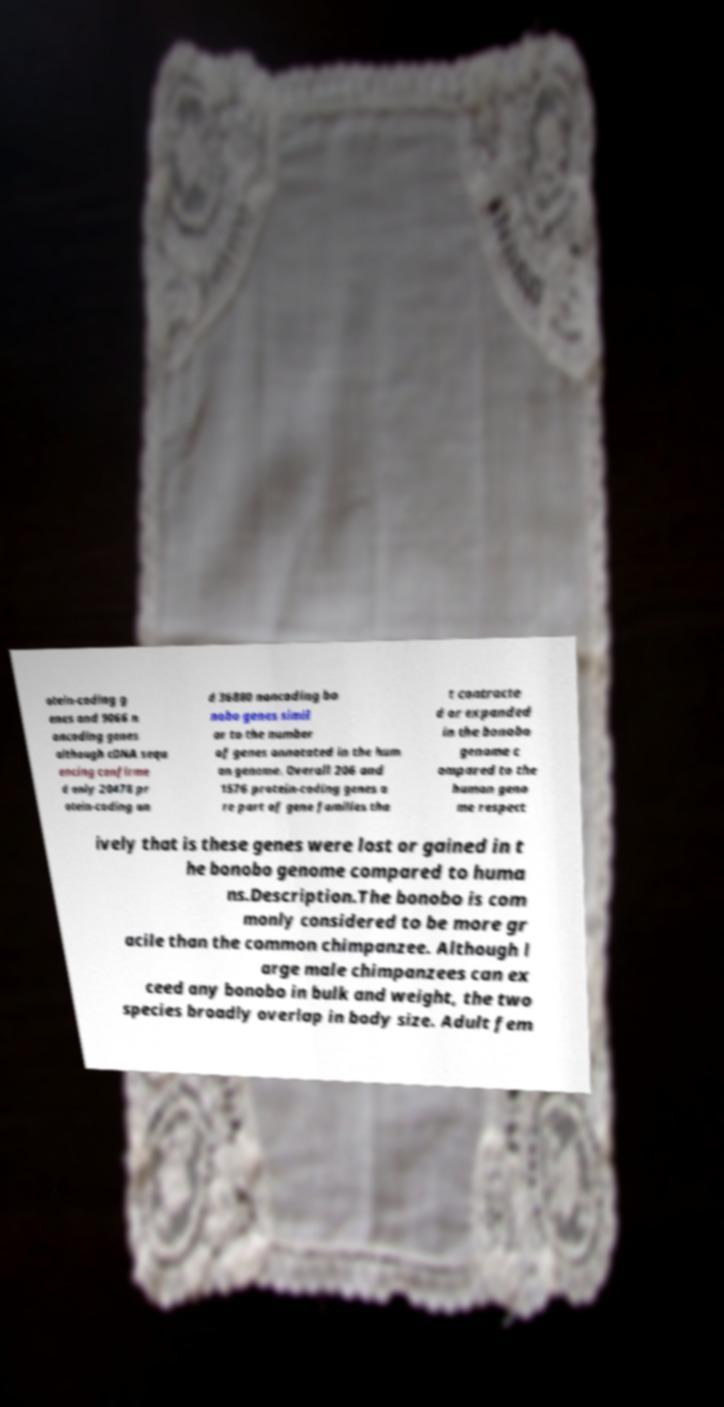I need the written content from this picture converted into text. Can you do that? otein-coding g enes and 9066 n oncoding genes although cDNA sequ encing confirme d only 20478 pr otein-coding an d 36880 noncoding bo nobo genes simil ar to the number of genes annotated in the hum an genome. Overall 206 and 1576 protein-coding genes a re part of gene families tha t contracte d or expanded in the bonobo genome c ompared to the human geno me respect ively that is these genes were lost or gained in t he bonobo genome compared to huma ns.Description.The bonobo is com monly considered to be more gr acile than the common chimpanzee. Although l arge male chimpanzees can ex ceed any bonobo in bulk and weight, the two species broadly overlap in body size. Adult fem 